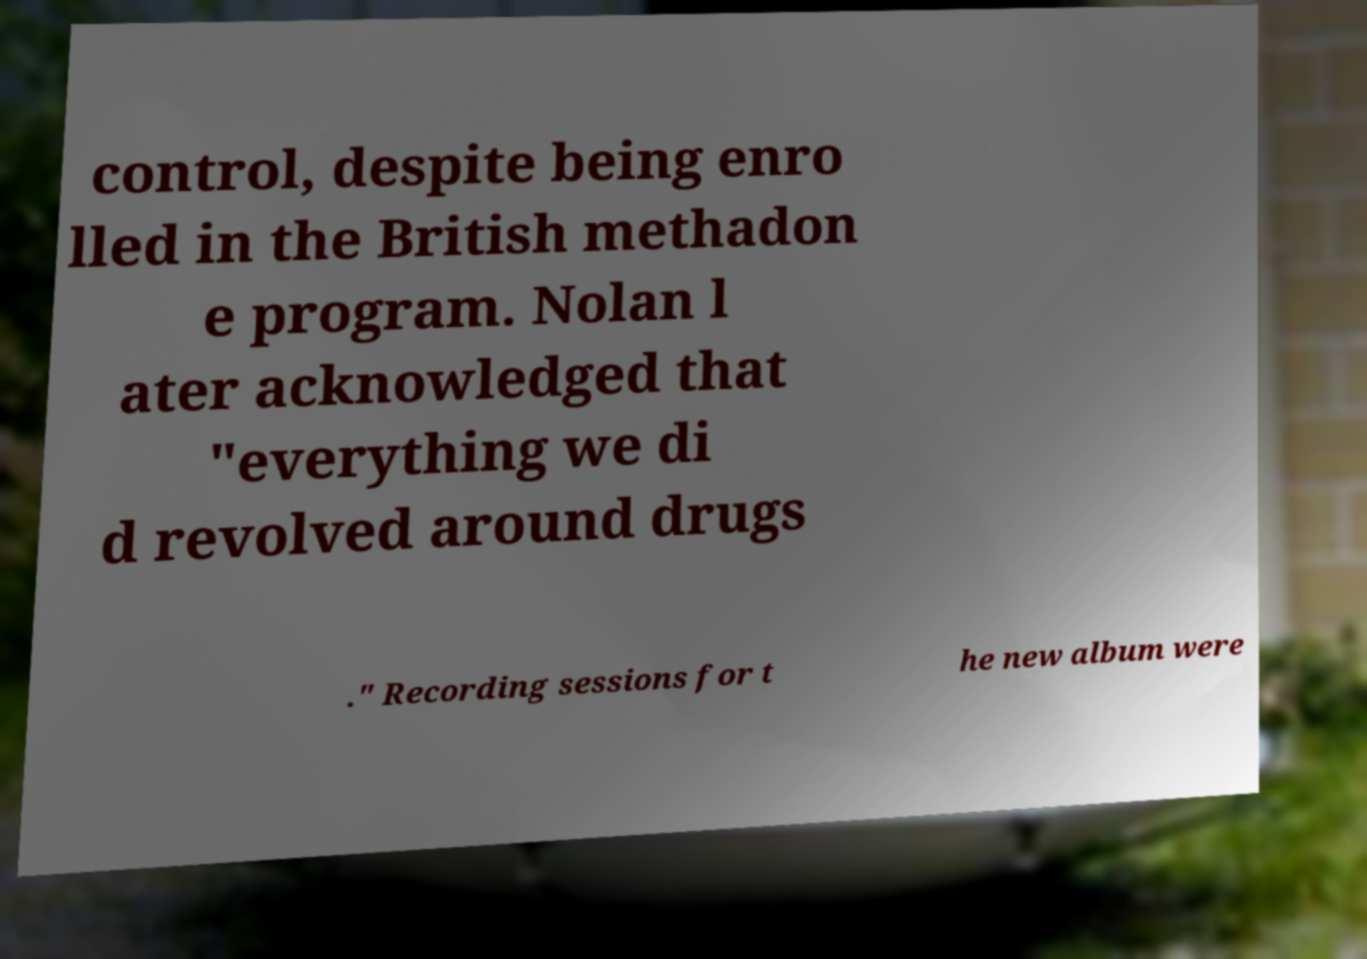Can you accurately transcribe the text from the provided image for me? control, despite being enro lled in the British methadon e program. Nolan l ater acknowledged that "everything we di d revolved around drugs ." Recording sessions for t he new album were 